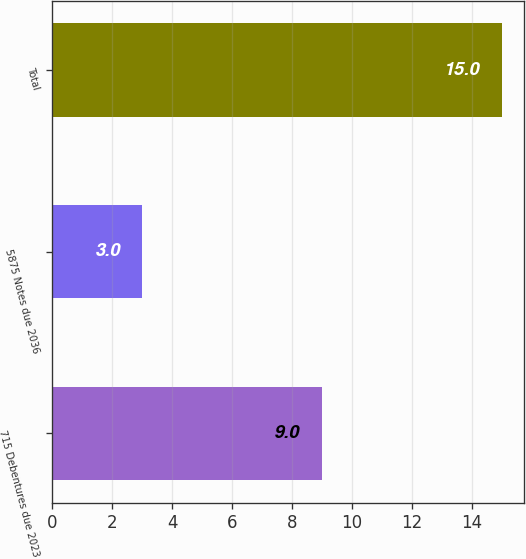<chart> <loc_0><loc_0><loc_500><loc_500><bar_chart><fcel>715 Debentures due 2023<fcel>5875 Notes due 2036<fcel>Total<nl><fcel>9<fcel>3<fcel>15<nl></chart> 